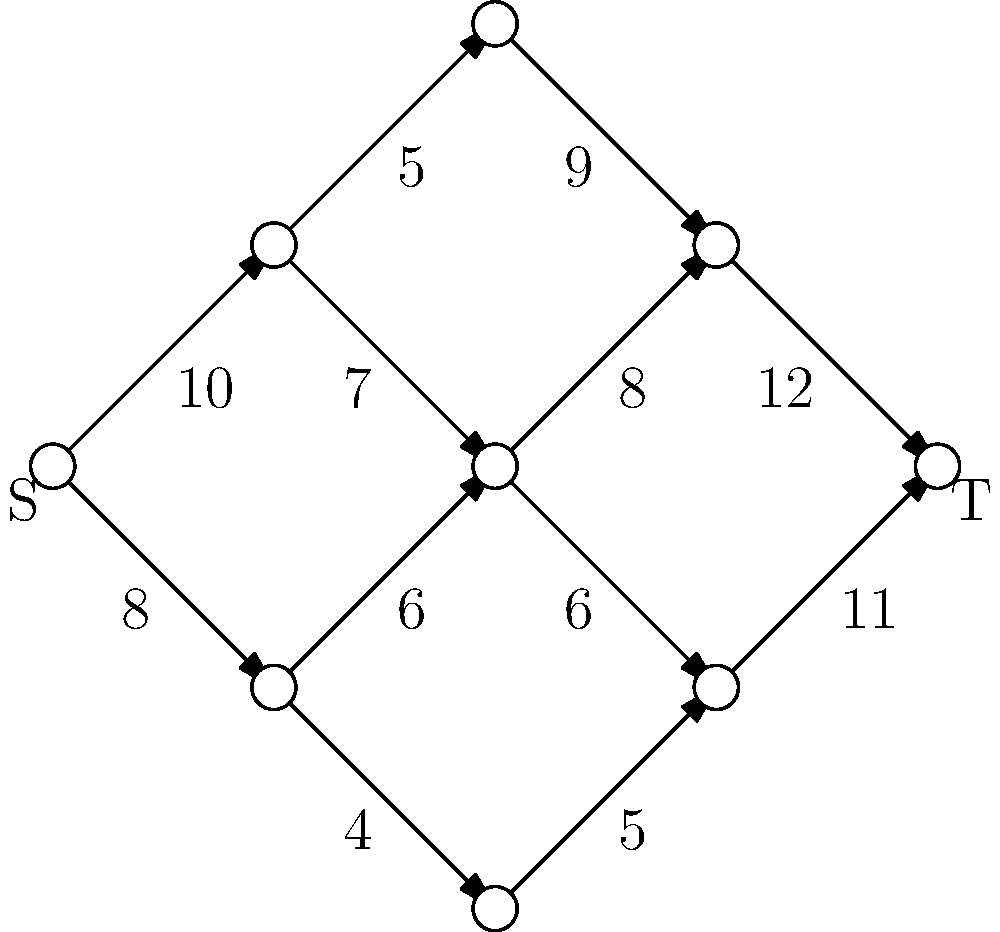As a supplier of railway parts, you need to maximize the flow of components through your supply chain network. The network is represented by the graph above, where S is the source (your main warehouse) and T is the sink (final assembly point). The numbers on the edges represent the maximum capacity of parts that can be transported along that route per day. What is the maximum flow of parts from S to T? To solve this problem, we'll use the Ford-Fulkerson algorithm to find the maximum flow in the network:

1. Initialize flow to 0.
2. Find an augmenting path from S to T using depth-first search (DFS).
3. Determine the minimum capacity along this path.
4. Add this capacity to the total flow.
5. Update residual graph capacities.
6. Repeat steps 2-5 until no augmenting path exists.

Let's apply the algorithm:

Path 1: S → v1 → v3 → v6 → T
Minimum capacity: 5
Flow: 5

Path 2: S → v1 → v4 → v6 → T
Minimum capacity: 7
Flow: 5 + 7 = 12

Path 3: S → v2 → v4 → v7 → T
Minimum capacity: 6
Flow: 12 + 6 = 18

Path 4: S → v2 → v5 → v7 → T
Minimum capacity: 2 (4 - 2 used in path 3)
Flow: 18 + 2 = 20

No more augmenting paths exist.

Therefore, the maximum flow from S to T is 20 parts per day.
Answer: 20 parts per day 